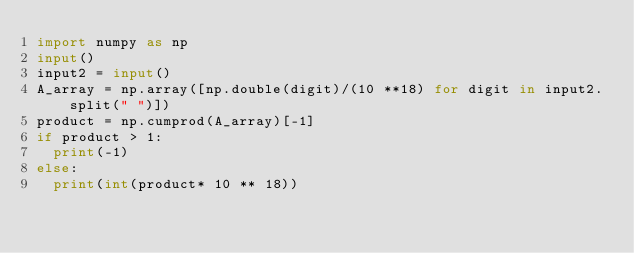Convert code to text. <code><loc_0><loc_0><loc_500><loc_500><_Python_>import numpy as np
input()
input2 = input()
A_array = np.array([np.double(digit)/(10 **18) for digit in input2.split(" ")])
product = np.cumprod(A_array)[-1]
if product > 1:
  print(-1)
else:
  print(int(product* 10 ** 18))</code> 